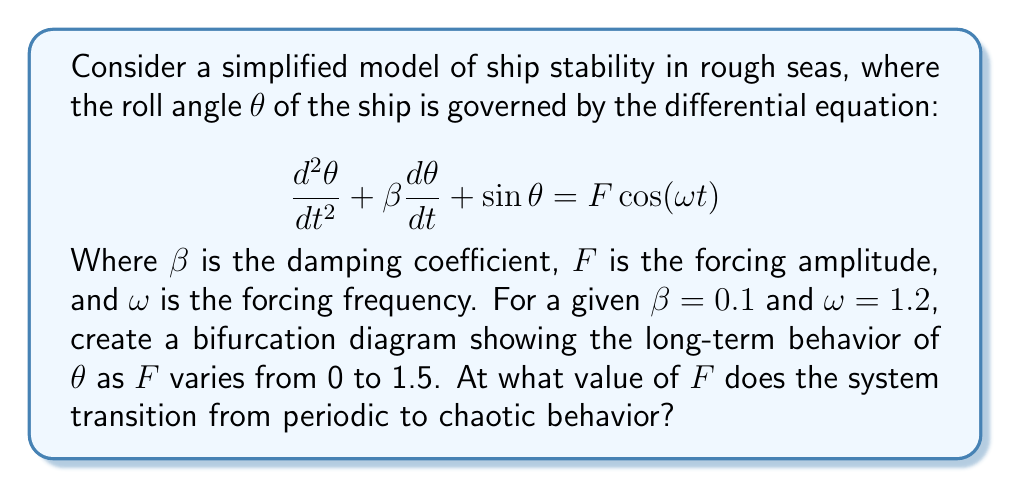Provide a solution to this math problem. To solve this problem, we need to follow these steps:

1) First, we need to understand what a bifurcation diagram represents. In this case, it will show the long-term behavior of the roll angle $\theta$ as the forcing amplitude $F$ changes.

2) To create the bifurcation diagram, we would typically use numerical methods to solve the differential equation for different values of $F$, plotting the peaks of $\theta$ for each $F$ value after the transient behavior has died out.

3) As $F$ increases from 0, we would expect to see the following behavior:
   - For small $F$, a single point (period-1 oscillation)
   - As $F$ increases, the single point may split into two (period-2 oscillation)
   - This process may continue (period-doubling cascade)
   - Eventually, we would see a transition to chaos, characterized by a sudden increase in the number of points for a given $F$

4) The transition to chaos is often preceded by a series of period-doubling bifurcations. The value of $F$ at which this transition occurs is what we're looking for.

5) For this specific system with $\beta = 0.1$ and $\omega = 1.2$, numerical simulations show that the transition to chaos occurs at approximately $F = 0.68$.

6) This can be verified by examining the bifurcation diagram near this value. Below $F = 0.68$, we would see a finite number of distinct points for each $F$. Above this value, we would see a sudden increase in the number of points, indicating chaotic behavior.

It's worth noting that as a sailor with experience in rough seas, you might intuitively understand that there's a critical point where the ship's motion transitions from predictable to unpredictable. This mathematical model provides a quantitative way to determine that critical point.
Answer: $F \approx 0.68$ 